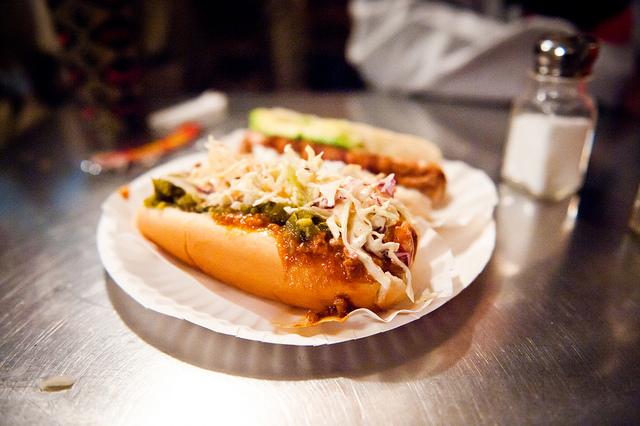Is the hot dog on a paper plate?
Short answer required. Yes. What is the white toppings on the hot dog?
Give a very brief answer. Cheese. Is there a beef or chicken hot dog?
Concise answer only. Beef. 